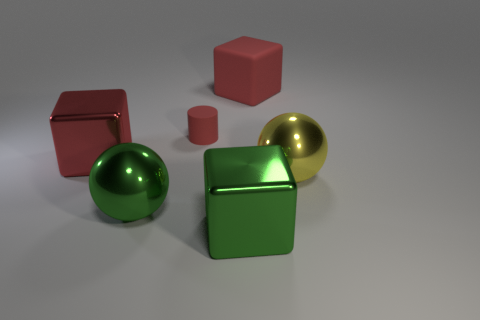Is there any other thing that has the same size as the red matte cylinder?
Your response must be concise. No. What number of big yellow spheres are in front of the yellow metal sphere?
Ensure brevity in your answer.  0. Is the number of small red matte things that are behind the tiny thing the same as the number of small yellow rubber balls?
Provide a succinct answer. Yes. What number of objects are big cylinders or large metal spheres?
Provide a short and direct response. 2. Are there any other things that are the same shape as the large red metallic object?
Provide a short and direct response. Yes. What is the shape of the red rubber thing that is to the left of the large thing that is behind the large red metal block?
Make the answer very short. Cylinder. There is a yellow object that is the same material as the large green sphere; what is its shape?
Provide a succinct answer. Sphere. There is a shiny sphere right of the large ball in front of the yellow shiny sphere; how big is it?
Your response must be concise. Large. What is the shape of the small rubber thing?
Your response must be concise. Cylinder. How many tiny things are either red balls or red matte objects?
Provide a short and direct response. 1. 